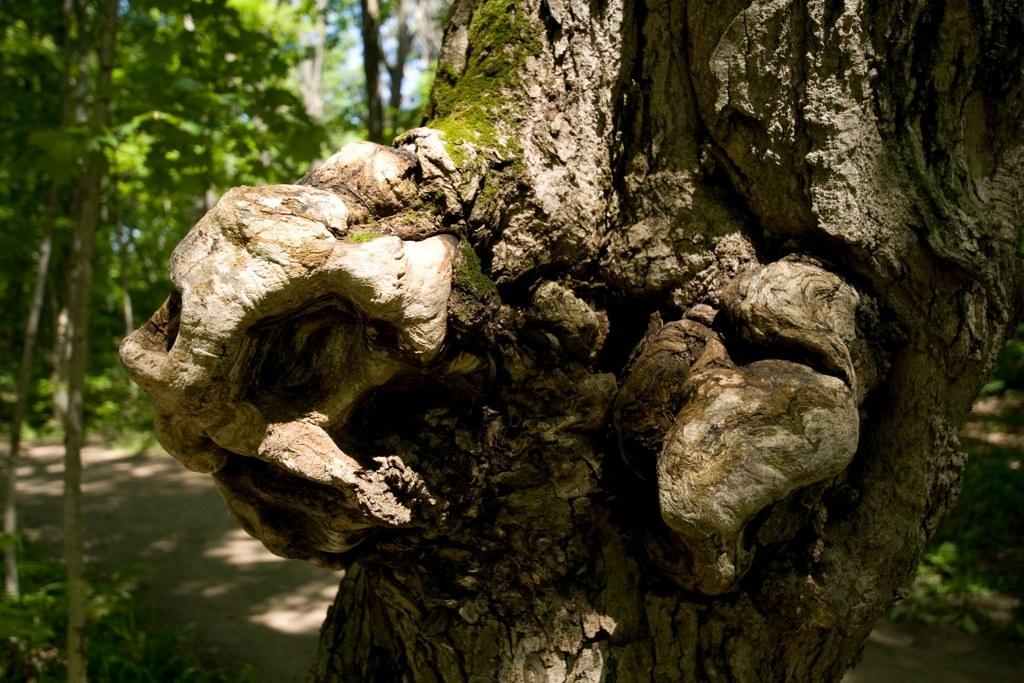What is the main subject of the image? The main subject of the image is the trunk of a tree. Are there any other trees visible in the image? Yes, there is a group of trees visible behind the trunk. What can be seen at the top of the image? The sky is visible at the top of the image. What type of advertisement can be seen on the edge of the carriage in the image? There is no carriage or advertisement present in the image; it features a tree trunk and a group of trees in the background. 